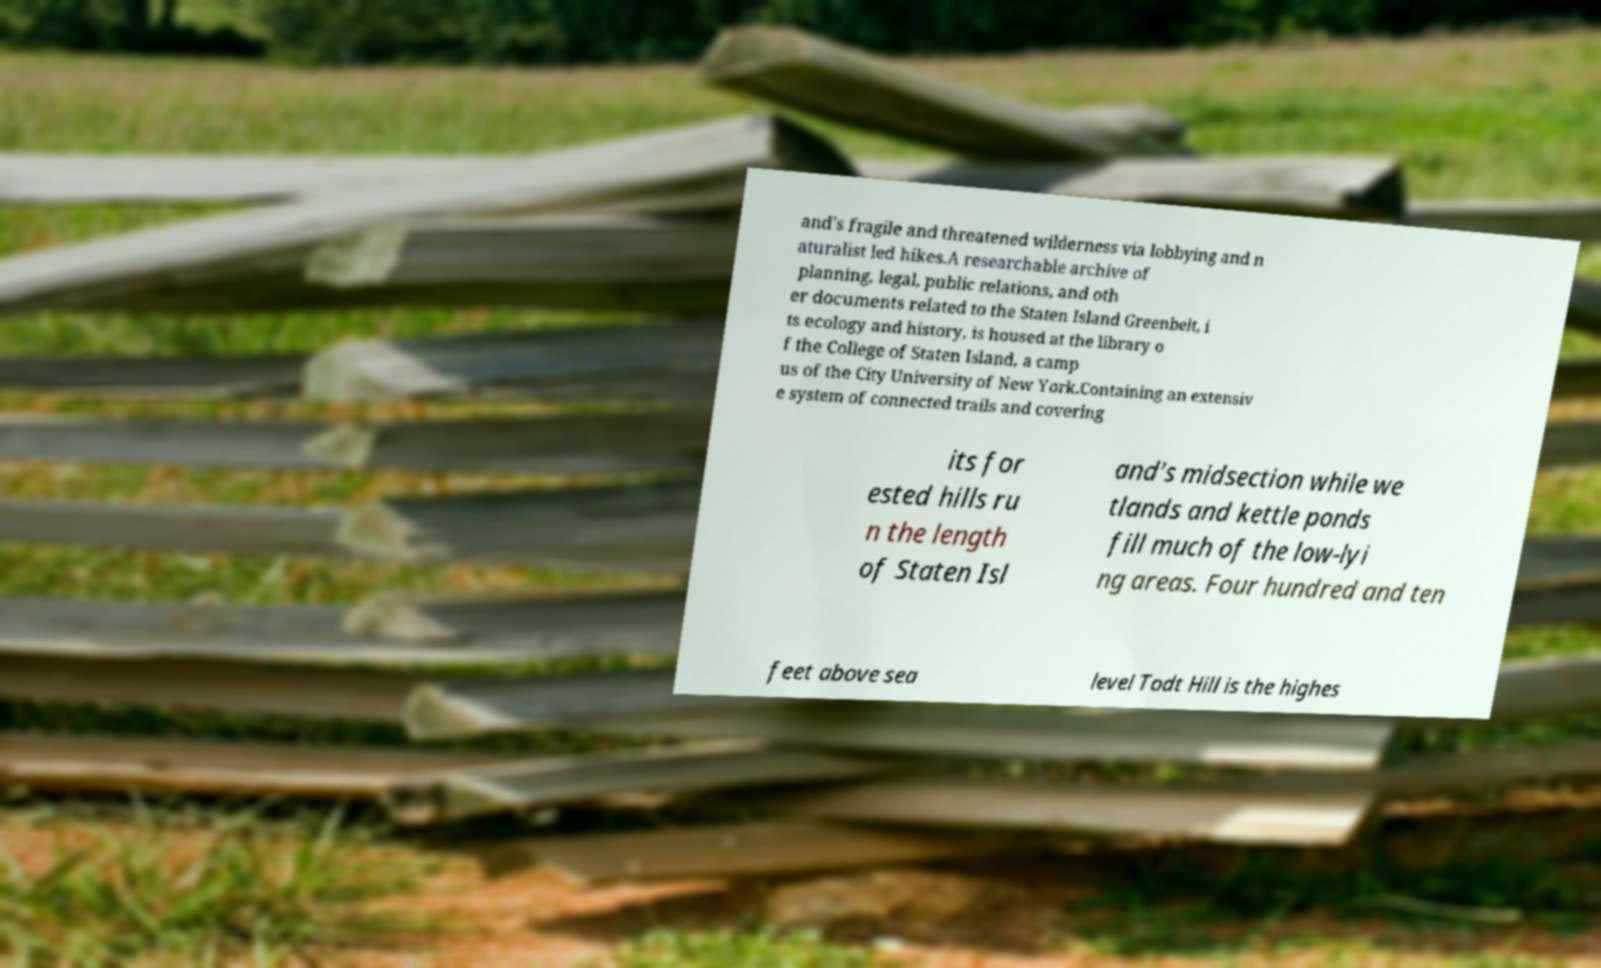Please read and relay the text visible in this image. What does it say? and's fragile and threatened wilderness via lobbying and n aturalist led hikes.A researchable archive of planning, legal, public relations, and oth er documents related to the Staten Island Greenbelt, i ts ecology and history, is housed at the library o f the College of Staten Island, a camp us of the City University of New York.Containing an extensiv e system of connected trails and covering its for ested hills ru n the length of Staten Isl and's midsection while we tlands and kettle ponds fill much of the low-lyi ng areas. Four hundred and ten feet above sea level Todt Hill is the highes 